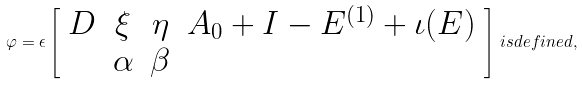<formula> <loc_0><loc_0><loc_500><loc_500>\varphi = \epsilon \left [ \begin{array} { c c c c } D & \xi & \eta & A _ { 0 } + I - E ^ { ( 1 ) } + \iota ( E ) \\ & \alpha & \beta \end{array} \right ] \, i s d e f i n e d ,</formula> 